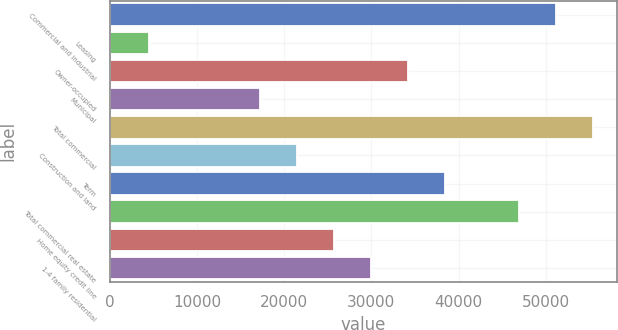Convert chart. <chart><loc_0><loc_0><loc_500><loc_500><bar_chart><fcel>Commercial and industrial<fcel>Leasing<fcel>Owner-occupied<fcel>Municipal<fcel>Total commercial<fcel>Construction and land<fcel>Term<fcel>Total commercial real estate<fcel>Home equity credit line<fcel>1-4 family residential<nl><fcel>51140.8<fcel>4435.9<fcel>34157.2<fcel>17173.6<fcel>55386.7<fcel>21419.5<fcel>38403.1<fcel>46894.9<fcel>25665.4<fcel>29911.3<nl></chart> 